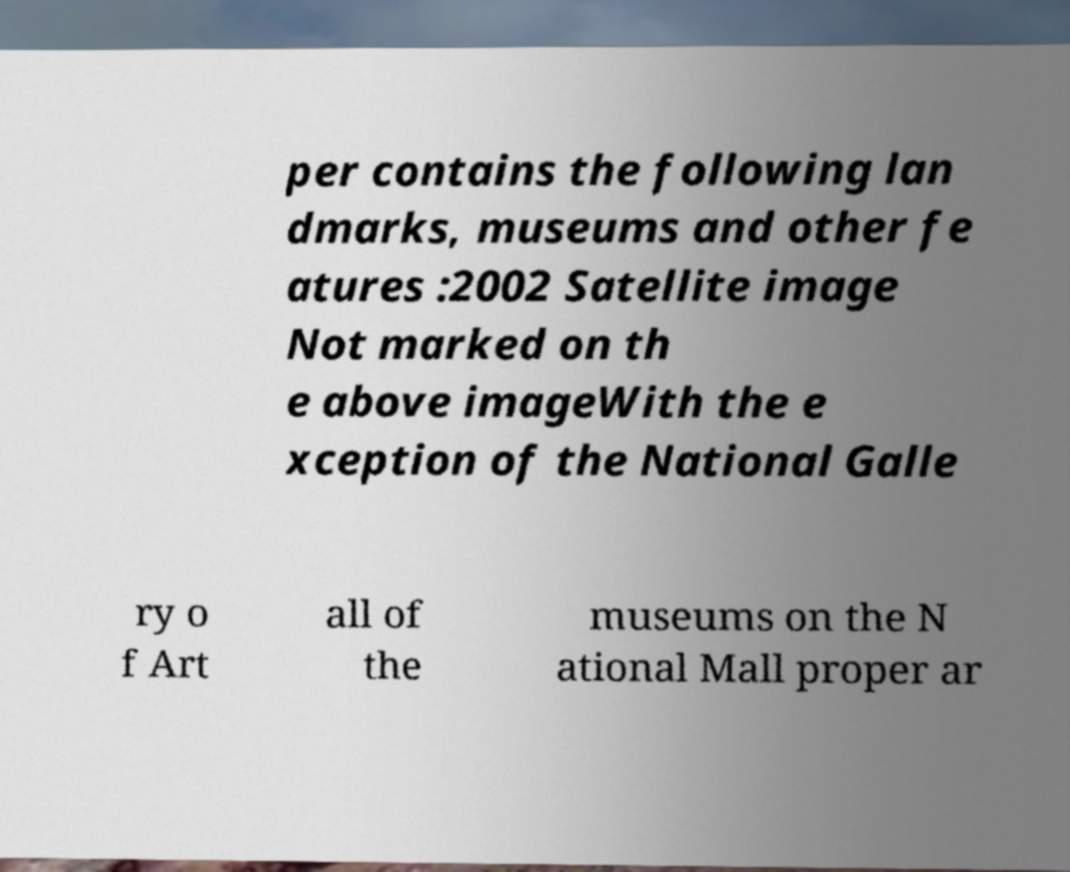What messages or text are displayed in this image? I need them in a readable, typed format. per contains the following lan dmarks, museums and other fe atures :2002 Satellite image Not marked on th e above imageWith the e xception of the National Galle ry o f Art all of the museums on the N ational Mall proper ar 